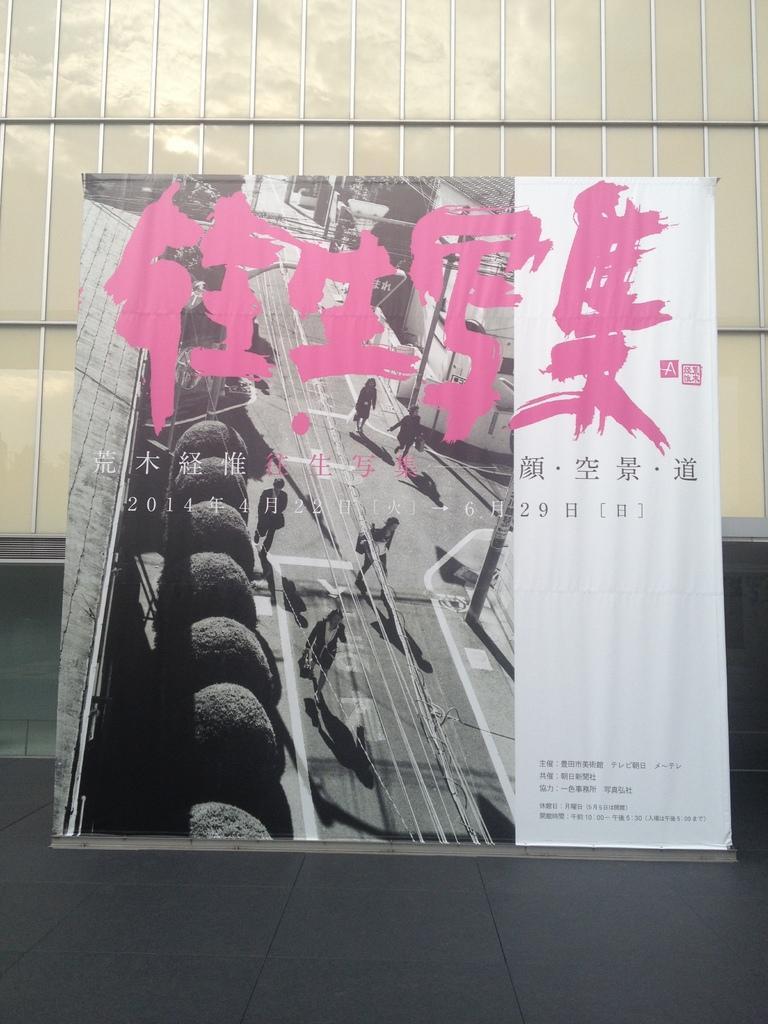Can you describe this image briefly? In the picture we can see a wall and a board with a painting on it with some people walking on it and besides it we can see some information. 